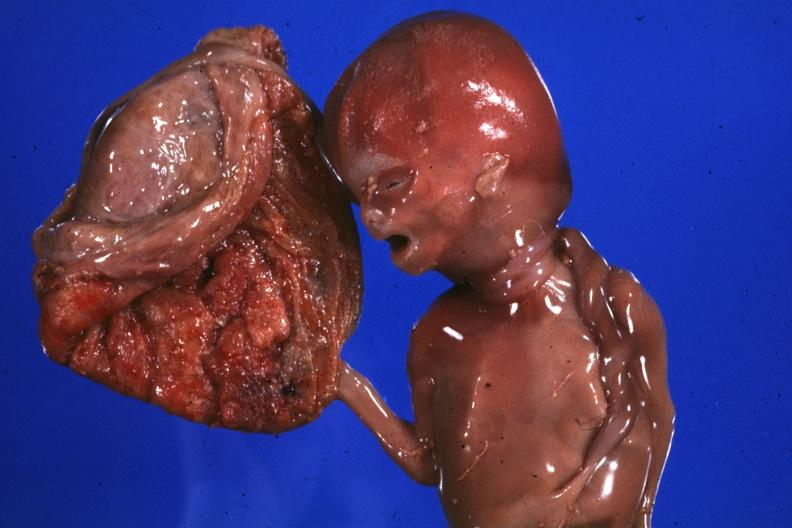how does this image show macerated stillborn?
Answer the question using a single word or phrase. With two loops of cord around neck good photo 